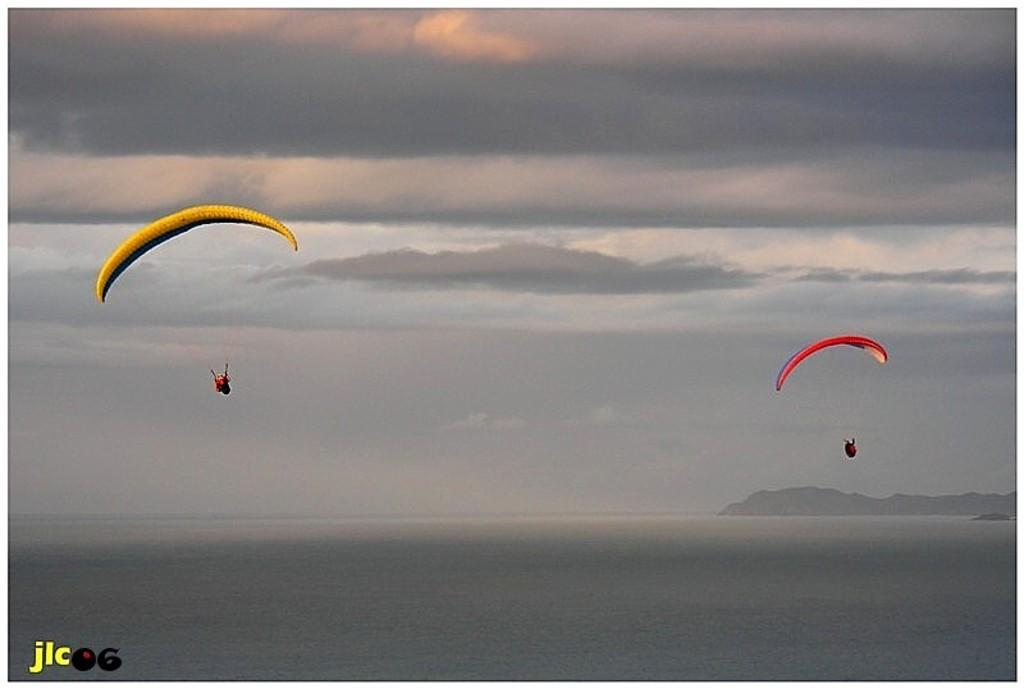What are the two persons in the image doing? The two persons in the image are parachuting in the sky. What are the parachuters using to descend safely? The parachuters are using parachutes. What can be seen below the parachuters in the image? There is water visible in the image, as well as hills. Is there any text or logo on the image? Yes, there is a watermark on the image. What type of bells can be heard ringing in the image? There are no bells present in the image, and therefore no sound can be heard. What material is the steel structure visible in the image made of? There is no steel structure visible in the image. What type of punishment is being administered to the parachuters in the image? There is no punishment being administered to the parachuters in the image; they are engaging in a recreational activity. 